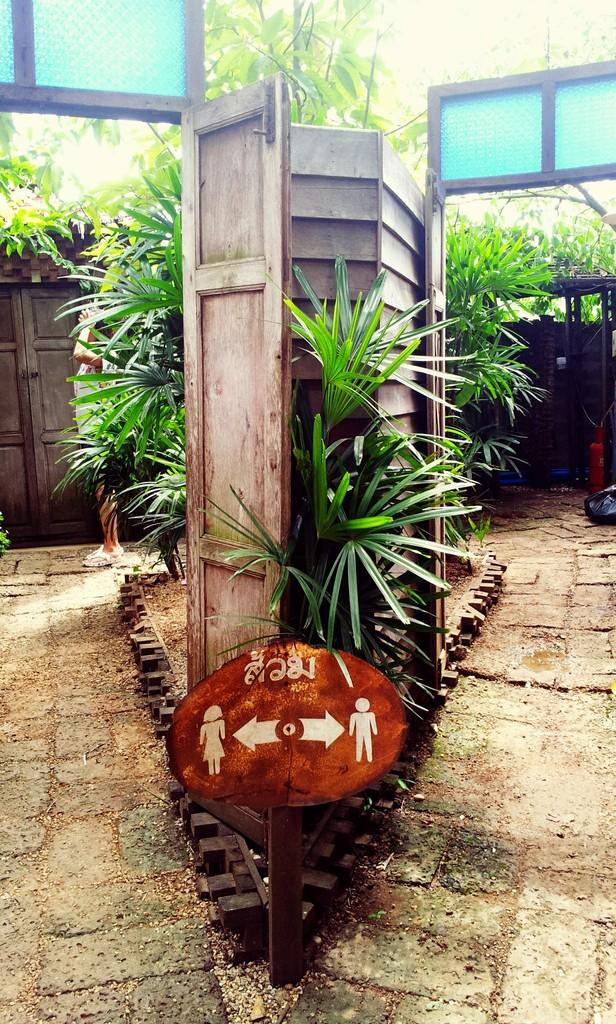What type of living organisms can be seen in the image? Plants can be seen in the image. What other objects are present in the image? Boards, poles, and doors are present in the image. Is there any indication of human presence in the image? Yes, there is a person standing on the ground in the image. How many pizzas can be seen on the ground in the image? There are no pizzas present in the image; it features plants, boards, poles, doors, and a person standing on the ground. Is there a pig visible in the image? There is no pig present in the image. 